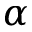Convert formula to latex. <formula><loc_0><loc_0><loc_500><loc_500>\alpha</formula> 